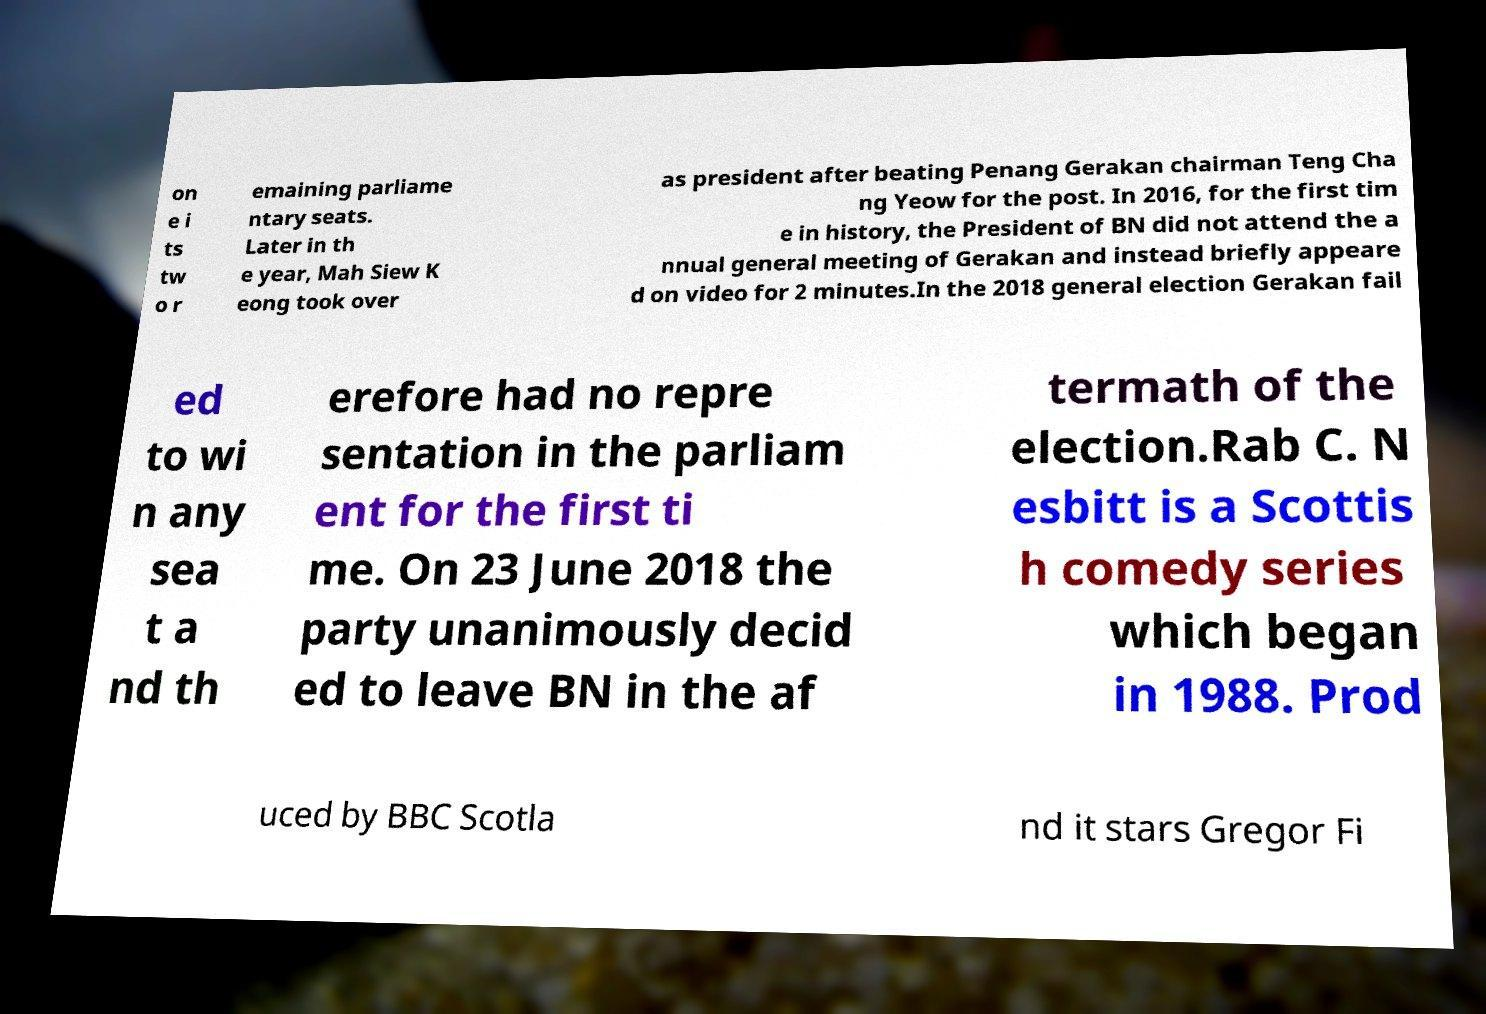Please identify and transcribe the text found in this image. on e i ts tw o r emaining parliame ntary seats. Later in th e year, Mah Siew K eong took over as president after beating Penang Gerakan chairman Teng Cha ng Yeow for the post. In 2016, for the first tim e in history, the President of BN did not attend the a nnual general meeting of Gerakan and instead briefly appeare d on video for 2 minutes.In the 2018 general election Gerakan fail ed to wi n any sea t a nd th erefore had no repre sentation in the parliam ent for the first ti me. On 23 June 2018 the party unanimously decid ed to leave BN in the af termath of the election.Rab C. N esbitt is a Scottis h comedy series which began in 1988. Prod uced by BBC Scotla nd it stars Gregor Fi 